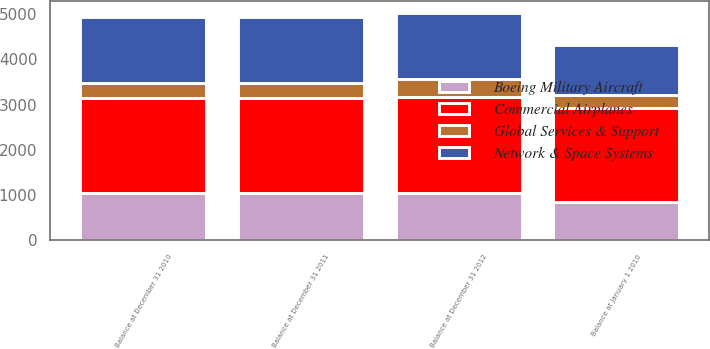Convert chart. <chart><loc_0><loc_0><loc_500><loc_500><stacked_bar_chart><ecel><fcel>Balance at January 1 2010<fcel>Balance at December 31 2010<fcel>Balance at December 31 2011<fcel>Balance at December 31 2012<nl><fcel>Commercial Airplanes<fcel>2083<fcel>2110<fcel>2106<fcel>2125<nl><fcel>Boeing Military Aircraft<fcel>848<fcel>1041<fcel>1041<fcel>1041<nl><fcel>Network & Space Systems<fcel>1102<fcel>1461<fcel>1473<fcel>1472<nl><fcel>Global Services & Support<fcel>286<fcel>325<fcel>325<fcel>397<nl></chart> 